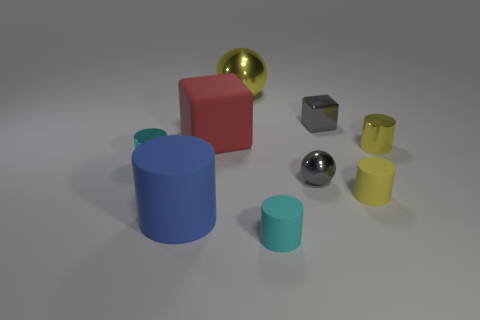Subtract all blue cylinders. How many cylinders are left? 4 Subtract all purple cylinders. Subtract all blue spheres. How many cylinders are left? 5 Add 1 blue shiny balls. How many objects exist? 10 Subtract all spheres. How many objects are left? 7 Subtract 0 purple cylinders. How many objects are left? 9 Subtract all small spheres. Subtract all tiny cyan metal cylinders. How many objects are left? 7 Add 6 gray metal spheres. How many gray metal spheres are left? 7 Add 5 small gray shiny objects. How many small gray shiny objects exist? 7 